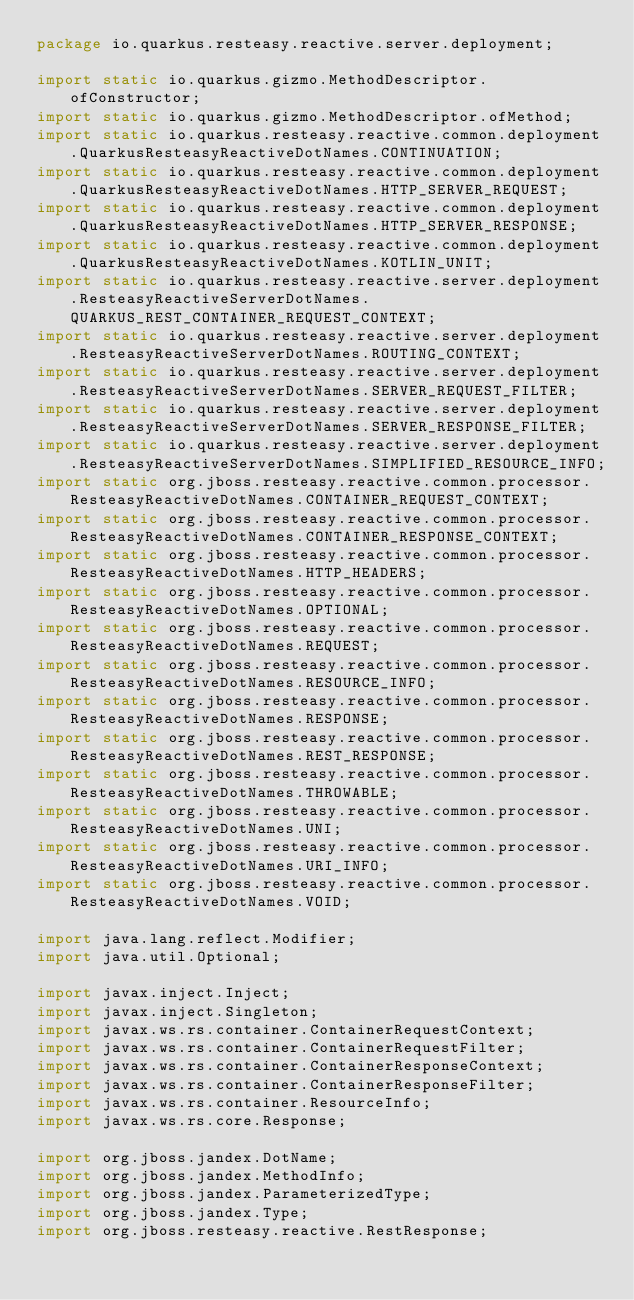<code> <loc_0><loc_0><loc_500><loc_500><_Java_>package io.quarkus.resteasy.reactive.server.deployment;

import static io.quarkus.gizmo.MethodDescriptor.ofConstructor;
import static io.quarkus.gizmo.MethodDescriptor.ofMethod;
import static io.quarkus.resteasy.reactive.common.deployment.QuarkusResteasyReactiveDotNames.CONTINUATION;
import static io.quarkus.resteasy.reactive.common.deployment.QuarkusResteasyReactiveDotNames.HTTP_SERVER_REQUEST;
import static io.quarkus.resteasy.reactive.common.deployment.QuarkusResteasyReactiveDotNames.HTTP_SERVER_RESPONSE;
import static io.quarkus.resteasy.reactive.common.deployment.QuarkusResteasyReactiveDotNames.KOTLIN_UNIT;
import static io.quarkus.resteasy.reactive.server.deployment.ResteasyReactiveServerDotNames.QUARKUS_REST_CONTAINER_REQUEST_CONTEXT;
import static io.quarkus.resteasy.reactive.server.deployment.ResteasyReactiveServerDotNames.ROUTING_CONTEXT;
import static io.quarkus.resteasy.reactive.server.deployment.ResteasyReactiveServerDotNames.SERVER_REQUEST_FILTER;
import static io.quarkus.resteasy.reactive.server.deployment.ResteasyReactiveServerDotNames.SERVER_RESPONSE_FILTER;
import static io.quarkus.resteasy.reactive.server.deployment.ResteasyReactiveServerDotNames.SIMPLIFIED_RESOURCE_INFO;
import static org.jboss.resteasy.reactive.common.processor.ResteasyReactiveDotNames.CONTAINER_REQUEST_CONTEXT;
import static org.jboss.resteasy.reactive.common.processor.ResteasyReactiveDotNames.CONTAINER_RESPONSE_CONTEXT;
import static org.jboss.resteasy.reactive.common.processor.ResteasyReactiveDotNames.HTTP_HEADERS;
import static org.jboss.resteasy.reactive.common.processor.ResteasyReactiveDotNames.OPTIONAL;
import static org.jboss.resteasy.reactive.common.processor.ResteasyReactiveDotNames.REQUEST;
import static org.jboss.resteasy.reactive.common.processor.ResteasyReactiveDotNames.RESOURCE_INFO;
import static org.jboss.resteasy.reactive.common.processor.ResteasyReactiveDotNames.RESPONSE;
import static org.jboss.resteasy.reactive.common.processor.ResteasyReactiveDotNames.REST_RESPONSE;
import static org.jboss.resteasy.reactive.common.processor.ResteasyReactiveDotNames.THROWABLE;
import static org.jboss.resteasy.reactive.common.processor.ResteasyReactiveDotNames.UNI;
import static org.jboss.resteasy.reactive.common.processor.ResteasyReactiveDotNames.URI_INFO;
import static org.jboss.resteasy.reactive.common.processor.ResteasyReactiveDotNames.VOID;

import java.lang.reflect.Modifier;
import java.util.Optional;

import javax.inject.Inject;
import javax.inject.Singleton;
import javax.ws.rs.container.ContainerRequestContext;
import javax.ws.rs.container.ContainerRequestFilter;
import javax.ws.rs.container.ContainerResponseContext;
import javax.ws.rs.container.ContainerResponseFilter;
import javax.ws.rs.container.ResourceInfo;
import javax.ws.rs.core.Response;

import org.jboss.jandex.DotName;
import org.jboss.jandex.MethodInfo;
import org.jboss.jandex.ParameterizedType;
import org.jboss.jandex.Type;
import org.jboss.resteasy.reactive.RestResponse;</code> 